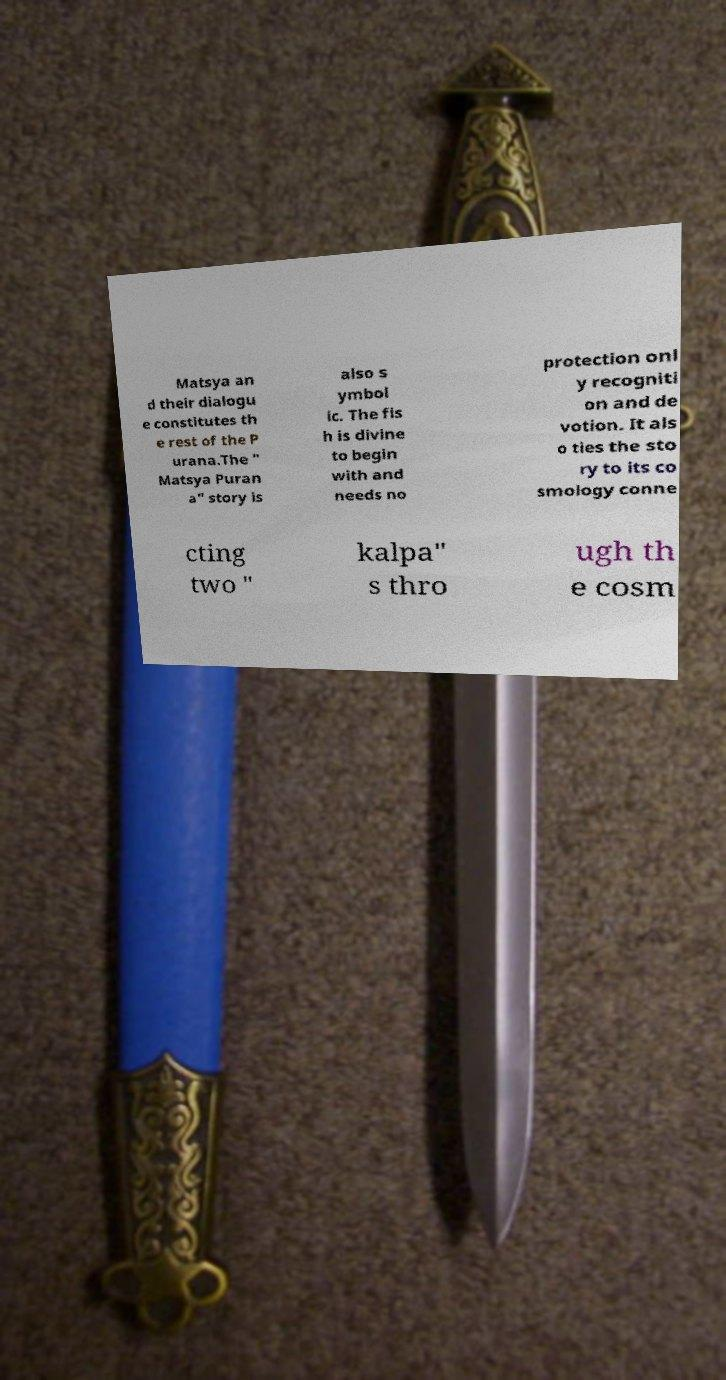Could you assist in decoding the text presented in this image and type it out clearly? Matsya an d their dialogu e constitutes th e rest of the P urana.The " Matsya Puran a" story is also s ymbol ic. The fis h is divine to begin with and needs no protection onl y recogniti on and de votion. It als o ties the sto ry to its co smology conne cting two " kalpa" s thro ugh th e cosm 